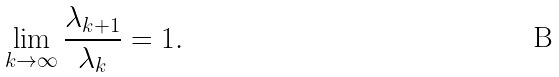<formula> <loc_0><loc_0><loc_500><loc_500>\lim _ { k \rightarrow \infty } \frac { \lambda _ { k + 1 } } { \lambda _ { k } } = 1 .</formula> 